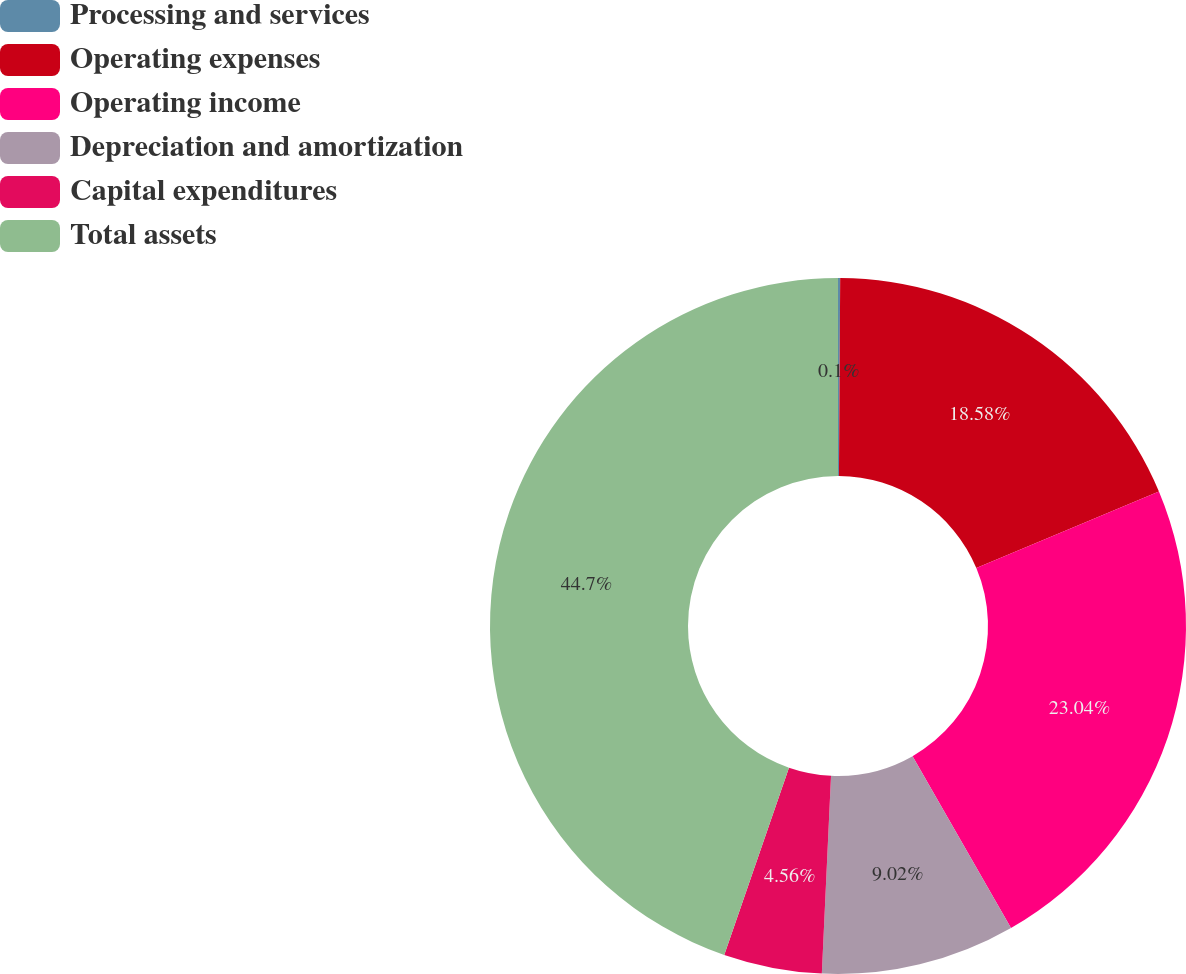<chart> <loc_0><loc_0><loc_500><loc_500><pie_chart><fcel>Processing and services<fcel>Operating expenses<fcel>Operating income<fcel>Depreciation and amortization<fcel>Capital expenditures<fcel>Total assets<nl><fcel>0.1%<fcel>18.58%<fcel>23.04%<fcel>9.02%<fcel>4.56%<fcel>44.7%<nl></chart> 